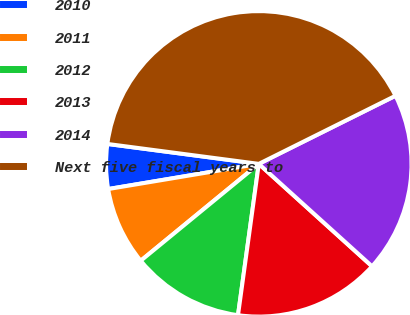<chart> <loc_0><loc_0><loc_500><loc_500><pie_chart><fcel>2010<fcel>2011<fcel>2012<fcel>2013<fcel>2014<fcel>Next five fiscal years to<nl><fcel>4.72%<fcel>8.3%<fcel>11.89%<fcel>15.47%<fcel>19.06%<fcel>40.56%<nl></chart> 